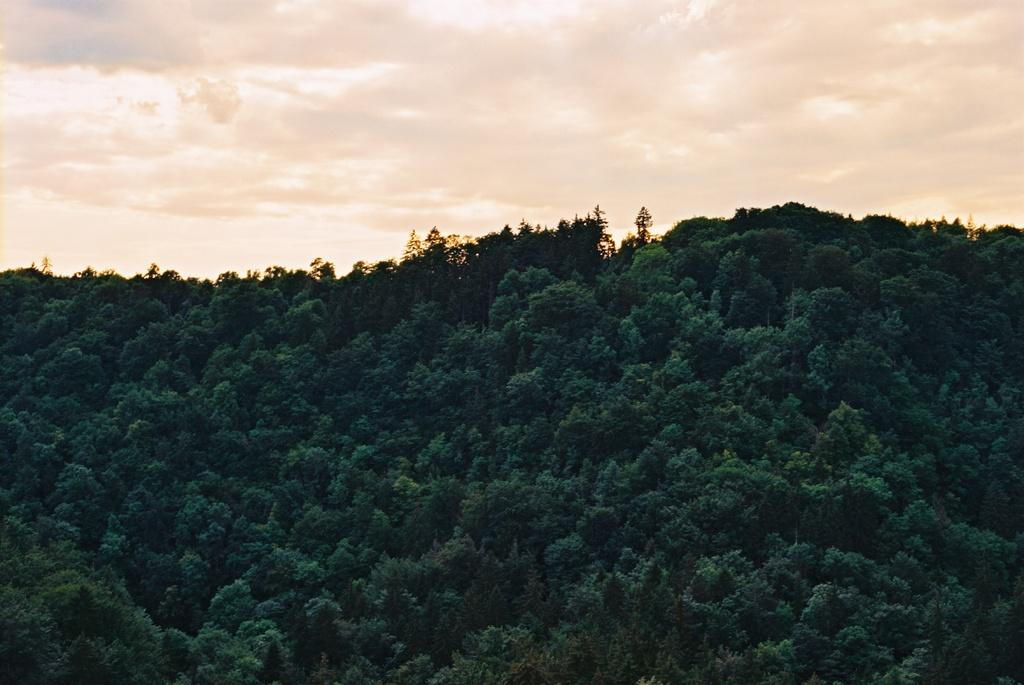What is the primary feature of the image? There are many trees in the image. What color are the trees? The trees are green in color. What can be seen in the background of the image? There are clouds and the sky visible in the background of the image. What type of hole can be seen in the image? There is no hole present in the image; it features many green trees and a background with clouds and the sky. 